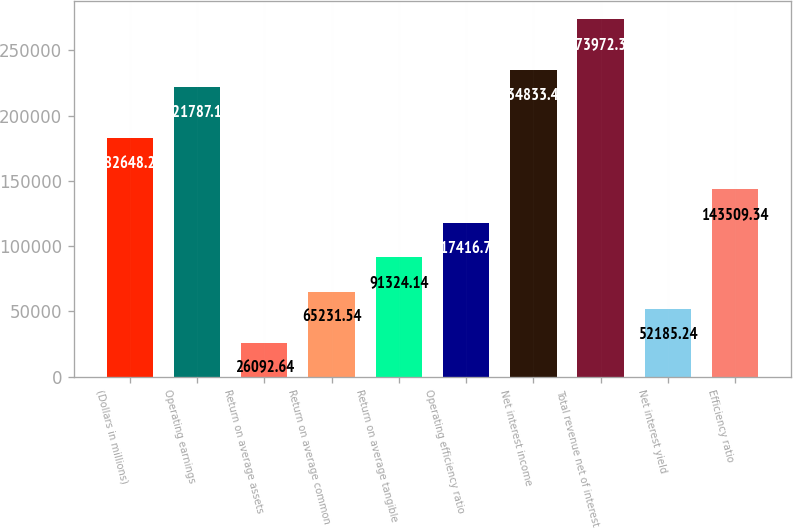Convert chart to OTSL. <chart><loc_0><loc_0><loc_500><loc_500><bar_chart><fcel>(Dollars in millions)<fcel>Operating earnings<fcel>Return on average assets<fcel>Return on average common<fcel>Return on average tangible<fcel>Operating efficiency ratio<fcel>Net interest income<fcel>Total revenue net of interest<fcel>Net interest yield<fcel>Efficiency ratio<nl><fcel>182648<fcel>221787<fcel>26092.6<fcel>65231.5<fcel>91324.1<fcel>117417<fcel>234833<fcel>273972<fcel>52185.2<fcel>143509<nl></chart> 